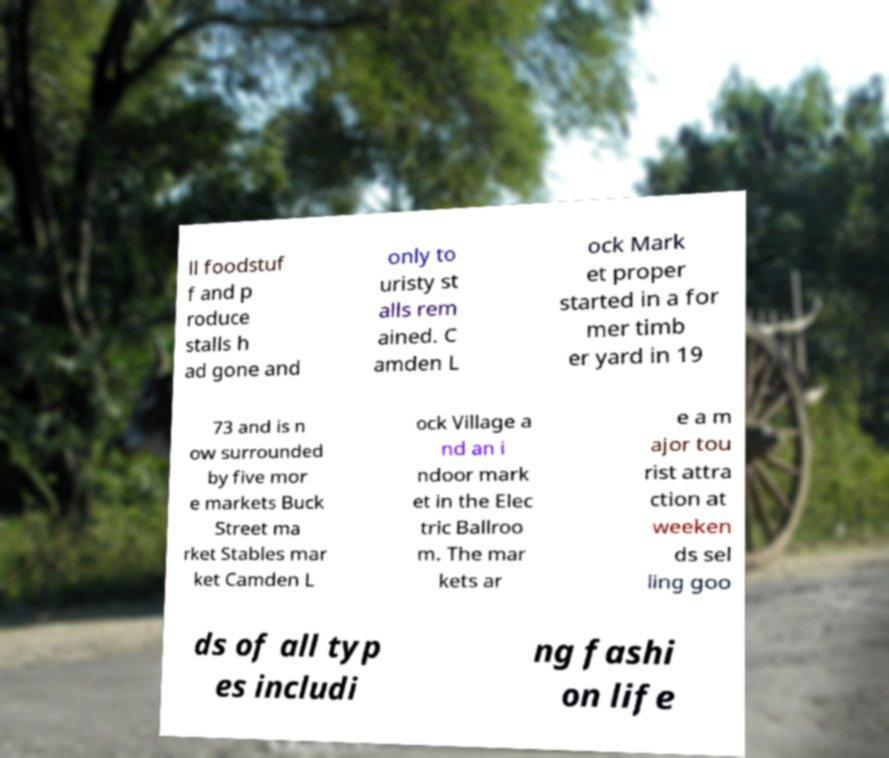Please identify and transcribe the text found in this image. ll foodstuf f and p roduce stalls h ad gone and only to uristy st alls rem ained. C amden L ock Mark et proper started in a for mer timb er yard in 19 73 and is n ow surrounded by five mor e markets Buck Street ma rket Stables mar ket Camden L ock Village a nd an i ndoor mark et in the Elec tric Ballroo m. The mar kets ar e a m ajor tou rist attra ction at weeken ds sel ling goo ds of all typ es includi ng fashi on life 